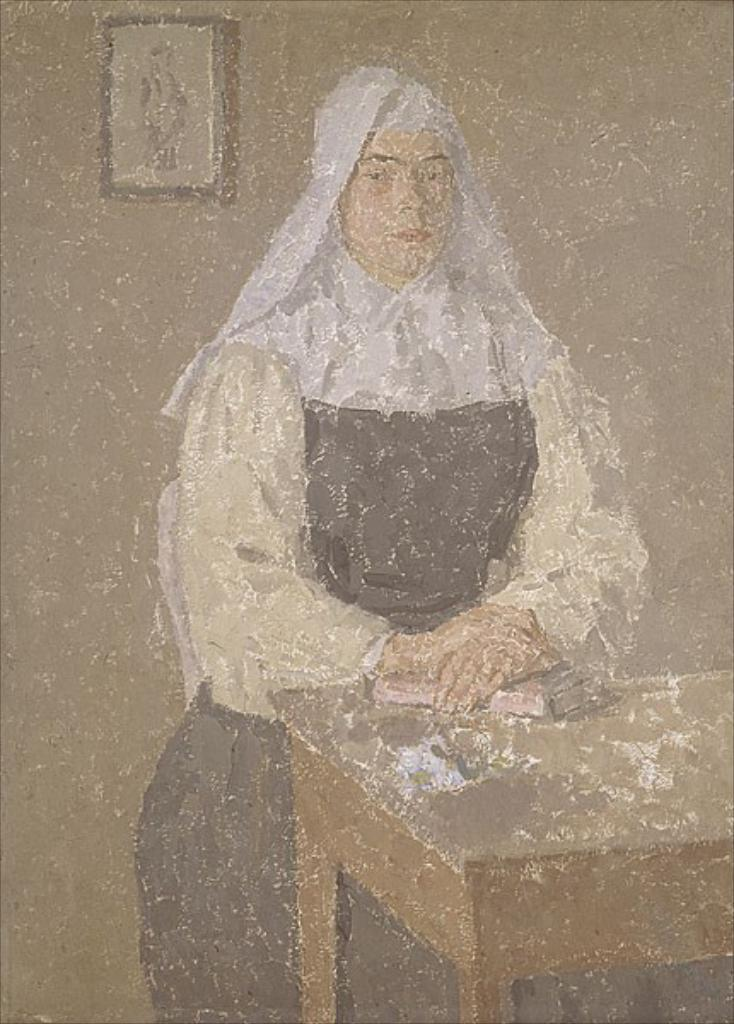What is depicted in the painting in the image? There is a painting of a woman in the image. What objects are on the table in front of the woman? There are books on a table in front of the woman. What can be seen on the wall behind the woman? There is a photo frame on the wall behind the woman. What type of pie is being served to the woman in the image? There is no pie present in the image; it features a painting of a woman, books on a table, and a photo frame on the wall. 